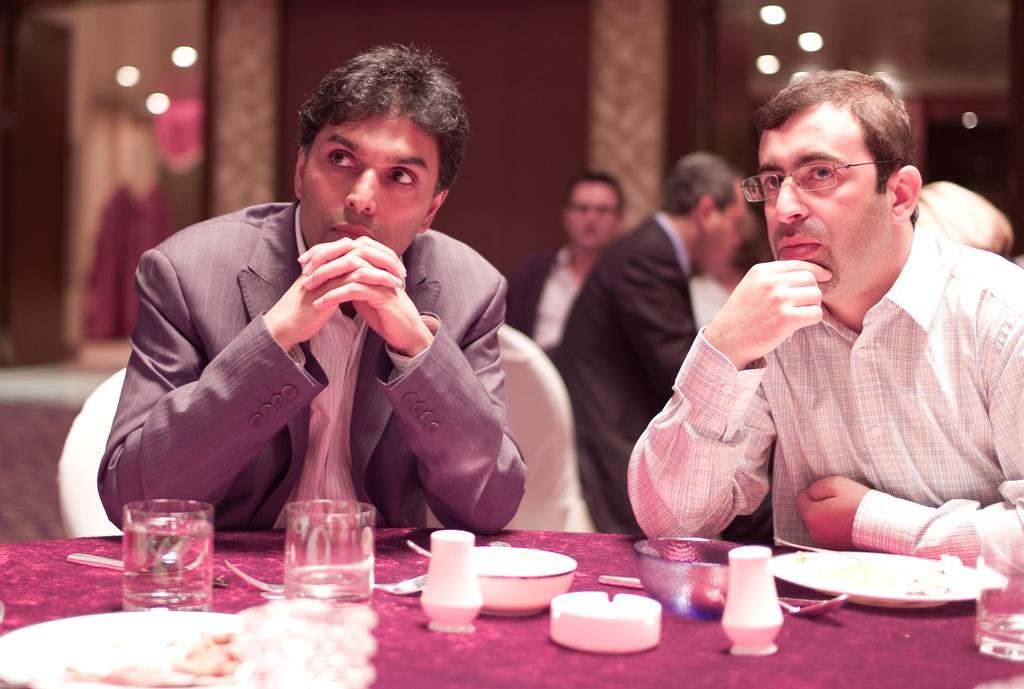Please provide a concise description of this image. In this picture there are two persons sitting on chairs and leaning on a table. A person towards the left, he is wearing a blazer. A person towards the right he is wearing a check shirt and spectacles. On the table there are some glasses, bowls and plates. In the background there are some more people, wall and lights. 